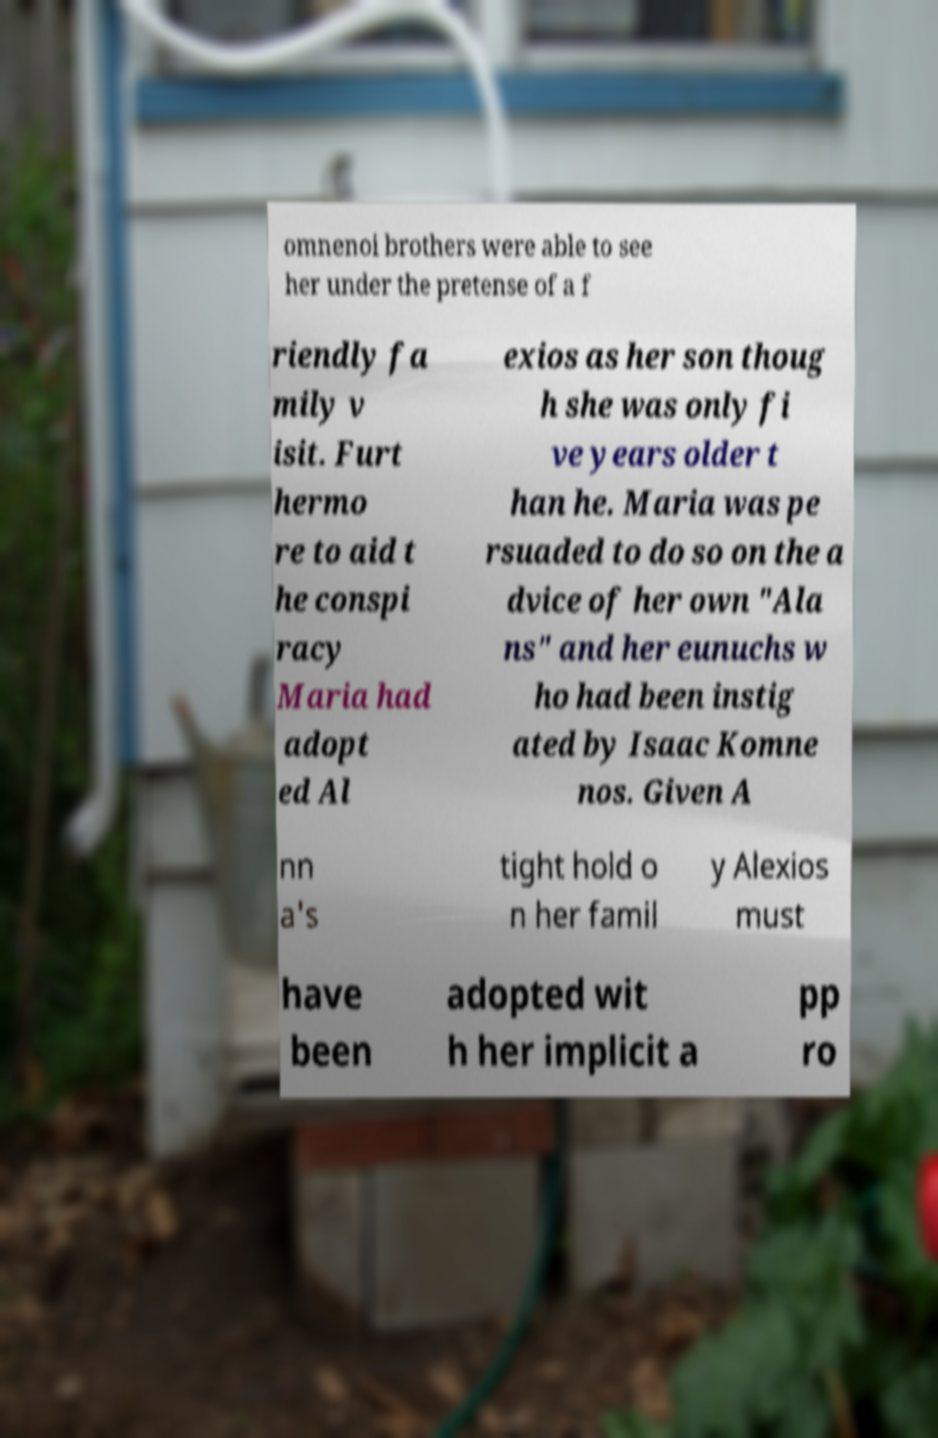Please identify and transcribe the text found in this image. omnenoi brothers were able to see her under the pretense of a f riendly fa mily v isit. Furt hermo re to aid t he conspi racy Maria had adopt ed Al exios as her son thoug h she was only fi ve years older t han he. Maria was pe rsuaded to do so on the a dvice of her own "Ala ns" and her eunuchs w ho had been instig ated by Isaac Komne nos. Given A nn a's tight hold o n her famil y Alexios must have been adopted wit h her implicit a pp ro 